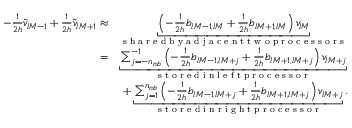<formula> <loc_0><loc_0><loc_500><loc_500>\begin{array} { r l } { - \frac { 1 } { 2 h } \widetilde { v } _ { l M - 1 } + \frac { 1 } { 2 h } \widetilde { v } _ { l M + 1 } \approx } & { \underbracket { \left ( - \frac { 1 } { 2 h } b _ { l M - 1 , l M } + \frac { 1 } { 2 h } b _ { l M + 1 , l M } \right ) v _ { l M } } _ { s h a r e d b y a d j a c e n t t w o p r o c e s s o r s } } \\ { = } & { \underbracket { \sum _ { j = - n _ { n b } } ^ { - 1 } \left ( - \frac { 1 } { 2 h } b _ { l M - 1 , l M + j } + \frac { 1 } { 2 h } b _ { l M + 1 , l M + j } \right ) v _ { l M + j } } _ { s t o r e d i n l e f t p r o c e s s o r } } \\ & { + \underbracket { \sum _ { j = 1 } ^ { n _ { n b } } \left ( - \frac { 1 } { 2 h } b _ { l M - 1 , l M + j } + \frac { 1 } { 2 h } b _ { l M + 1 , l M + j } \right ) v _ { l M + j } } _ { s t o r e d i n r i g h t p r o c e s s o r } . } \end{array}</formula> 